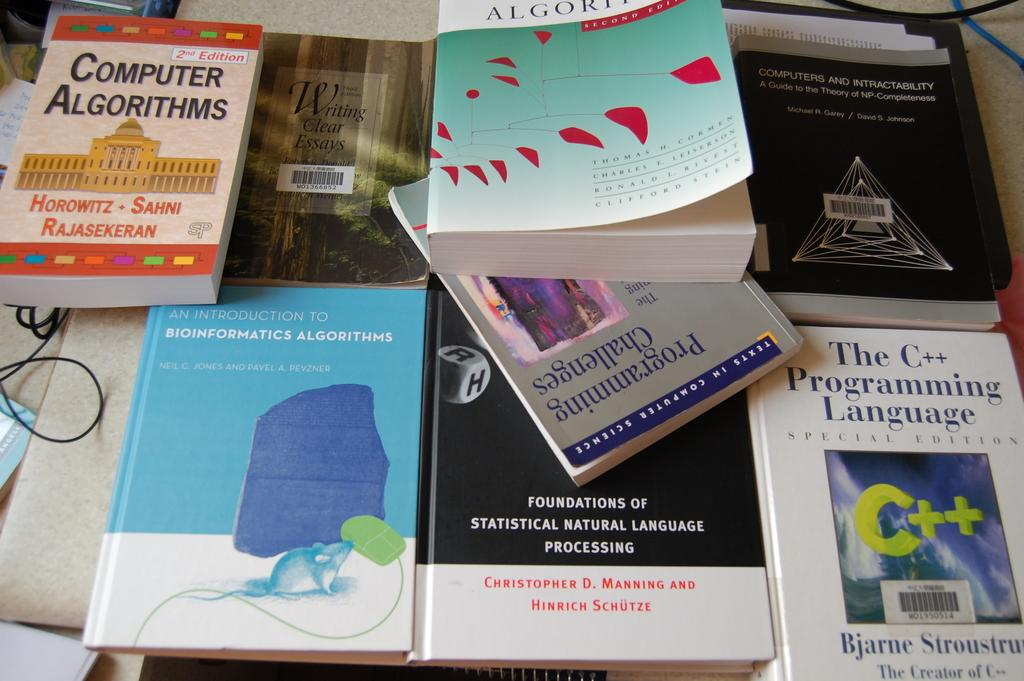<image>
Describe the image concisely. A book about computer algorithms has a classical style building on the cover. 